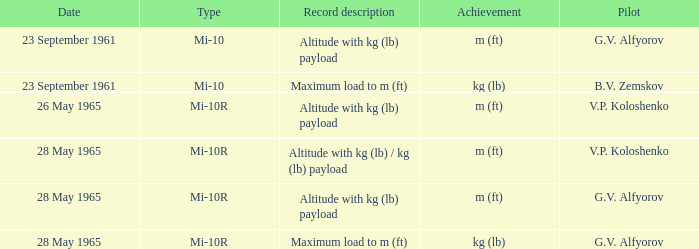Can you give me this table as a dict? {'header': ['Date', 'Type', 'Record description', 'Achievement', 'Pilot'], 'rows': [['23 September 1961', 'Mi-10', 'Altitude with kg (lb) payload', 'm (ft)', 'G.V. Alfyorov'], ['23 September 1961', 'Mi-10', 'Maximum load to m (ft)', 'kg (lb)', 'B.V. Zemskov'], ['26 May 1965', 'Mi-10R', 'Altitude with kg (lb) payload', 'm (ft)', 'V.P. Koloshenko'], ['28 May 1965', 'Mi-10R', 'Altitude with kg (lb) / kg (lb) payload', 'm (ft)', 'V.P. Koloshenko'], ['28 May 1965', 'Mi-10R', 'Altitude with kg (lb) payload', 'm (ft)', 'G.V. Alfyorov'], ['28 May 1965', 'Mi-10R', 'Maximum load to m (ft)', 'kg (lb)', 'G.V. Alfyorov']]} What kind of altitude achievement, carrying a payload in kg (lb), did pilot g.v. alfyorov accomplish? Mi-10, Mi-10R. 